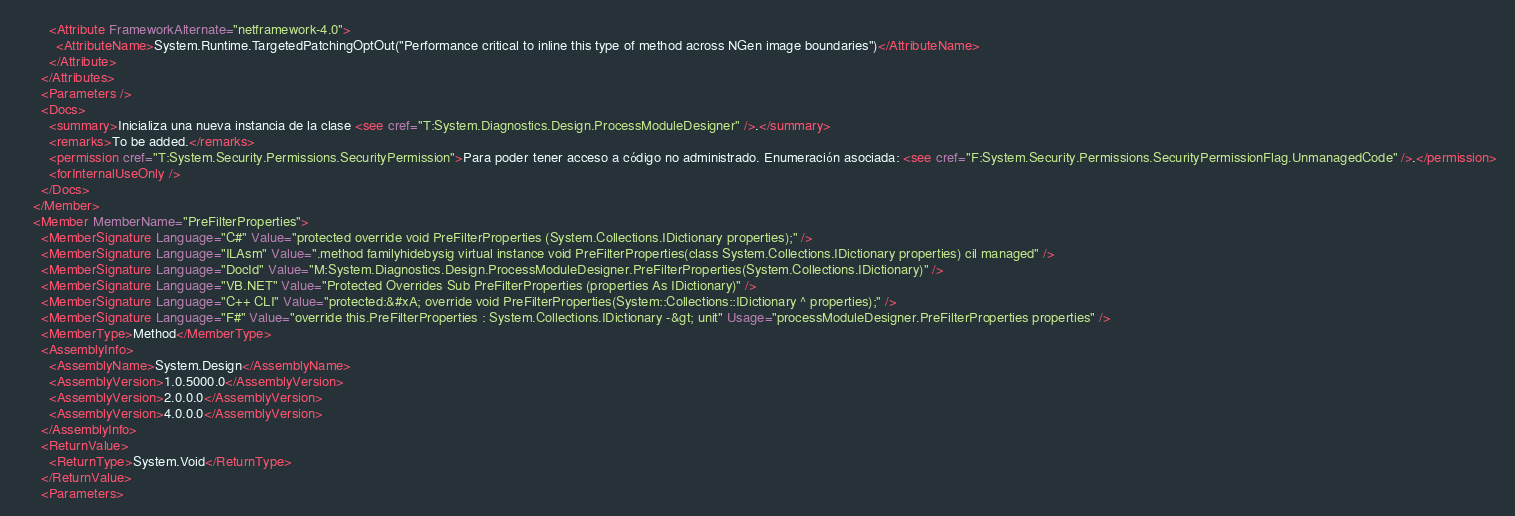Convert code to text. <code><loc_0><loc_0><loc_500><loc_500><_XML_>        <Attribute FrameworkAlternate="netframework-4.0">
          <AttributeName>System.Runtime.TargetedPatchingOptOut("Performance critical to inline this type of method across NGen image boundaries")</AttributeName>
        </Attribute>
      </Attributes>
      <Parameters />
      <Docs>
        <summary>Inicializa una nueva instancia de la clase <see cref="T:System.Diagnostics.Design.ProcessModuleDesigner" />.</summary>
        <remarks>To be added.</remarks>
        <permission cref="T:System.Security.Permissions.SecurityPermission">Para poder tener acceso a código no administrado. Enumeración asociada: <see cref="F:System.Security.Permissions.SecurityPermissionFlag.UnmanagedCode" />.</permission>
        <forInternalUseOnly />
      </Docs>
    </Member>
    <Member MemberName="PreFilterProperties">
      <MemberSignature Language="C#" Value="protected override void PreFilterProperties (System.Collections.IDictionary properties);" />
      <MemberSignature Language="ILAsm" Value=".method familyhidebysig virtual instance void PreFilterProperties(class System.Collections.IDictionary properties) cil managed" />
      <MemberSignature Language="DocId" Value="M:System.Diagnostics.Design.ProcessModuleDesigner.PreFilterProperties(System.Collections.IDictionary)" />
      <MemberSignature Language="VB.NET" Value="Protected Overrides Sub PreFilterProperties (properties As IDictionary)" />
      <MemberSignature Language="C++ CLI" Value="protected:&#xA; override void PreFilterProperties(System::Collections::IDictionary ^ properties);" />
      <MemberSignature Language="F#" Value="override this.PreFilterProperties : System.Collections.IDictionary -&gt; unit" Usage="processModuleDesigner.PreFilterProperties properties" />
      <MemberType>Method</MemberType>
      <AssemblyInfo>
        <AssemblyName>System.Design</AssemblyName>
        <AssemblyVersion>1.0.5000.0</AssemblyVersion>
        <AssemblyVersion>2.0.0.0</AssemblyVersion>
        <AssemblyVersion>4.0.0.0</AssemblyVersion>
      </AssemblyInfo>
      <ReturnValue>
        <ReturnType>System.Void</ReturnType>
      </ReturnValue>
      <Parameters></code> 